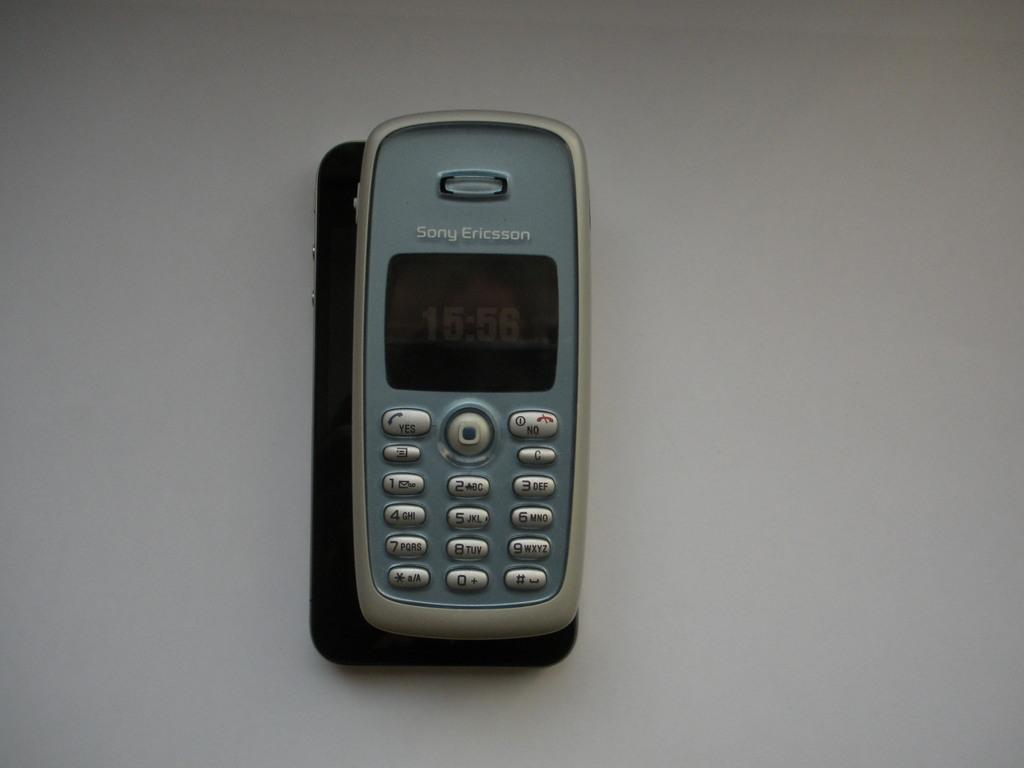<image>
Share a concise interpretation of the image provided. Sony Ericsson smartphone that says 15:56 on the front screen. 